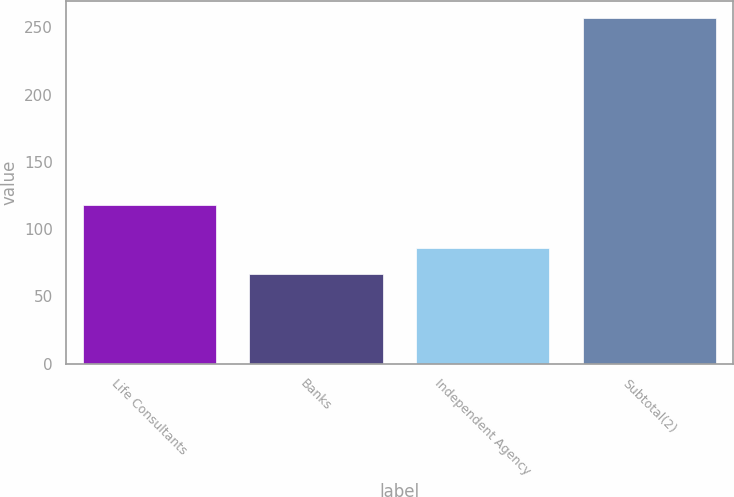Convert chart. <chart><loc_0><loc_0><loc_500><loc_500><bar_chart><fcel>Life Consultants<fcel>Banks<fcel>Independent Agency<fcel>Subtotal(2)<nl><fcel>118<fcel>67<fcel>86<fcel>257<nl></chart> 